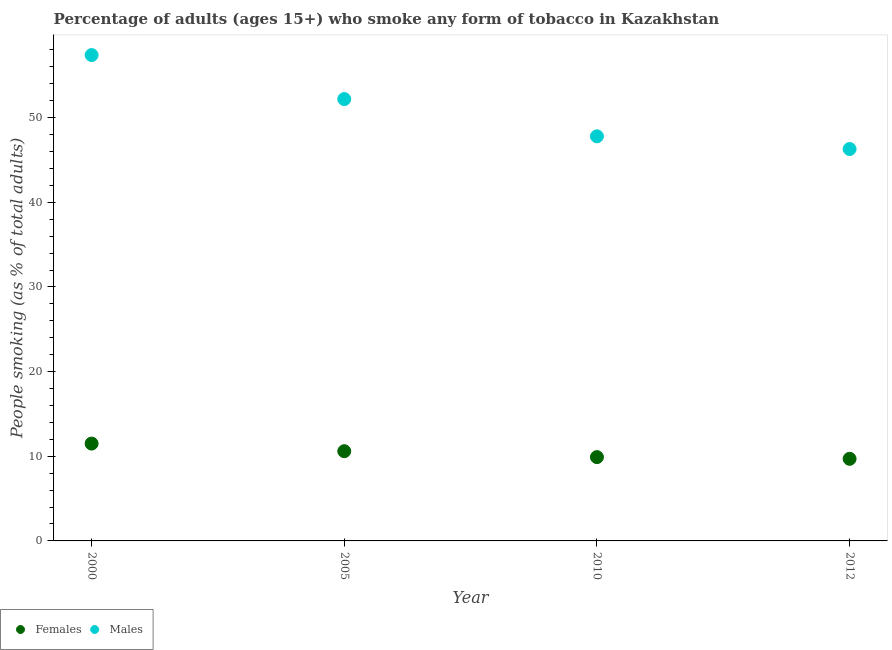Is the number of dotlines equal to the number of legend labels?
Offer a very short reply. Yes. What is the percentage of males who smoke in 2010?
Make the answer very short. 47.8. Across all years, what is the maximum percentage of males who smoke?
Ensure brevity in your answer.  57.4. Across all years, what is the minimum percentage of females who smoke?
Keep it short and to the point. 9.7. In which year was the percentage of males who smoke maximum?
Offer a terse response. 2000. In which year was the percentage of males who smoke minimum?
Give a very brief answer. 2012. What is the total percentage of females who smoke in the graph?
Make the answer very short. 41.7. What is the difference between the percentage of females who smoke in 2000 and that in 2012?
Offer a very short reply. 1.8. What is the difference between the percentage of males who smoke in 2012 and the percentage of females who smoke in 2005?
Give a very brief answer. 35.7. What is the average percentage of females who smoke per year?
Provide a succinct answer. 10.43. In the year 2012, what is the difference between the percentage of females who smoke and percentage of males who smoke?
Give a very brief answer. -36.6. What is the ratio of the percentage of females who smoke in 2010 to that in 2012?
Ensure brevity in your answer.  1.02. Is the percentage of females who smoke in 2000 less than that in 2010?
Your answer should be compact. No. What is the difference between the highest and the second highest percentage of males who smoke?
Give a very brief answer. 5.2. What is the difference between the highest and the lowest percentage of females who smoke?
Ensure brevity in your answer.  1.8. In how many years, is the percentage of females who smoke greater than the average percentage of females who smoke taken over all years?
Provide a short and direct response. 2. Is the percentage of females who smoke strictly less than the percentage of males who smoke over the years?
Make the answer very short. Yes. How many years are there in the graph?
Make the answer very short. 4. What is the difference between two consecutive major ticks on the Y-axis?
Offer a very short reply. 10. Are the values on the major ticks of Y-axis written in scientific E-notation?
Your response must be concise. No. Does the graph contain any zero values?
Ensure brevity in your answer.  No. Does the graph contain grids?
Offer a terse response. No. How many legend labels are there?
Make the answer very short. 2. What is the title of the graph?
Offer a very short reply. Percentage of adults (ages 15+) who smoke any form of tobacco in Kazakhstan. Does "Manufacturing industries and construction" appear as one of the legend labels in the graph?
Give a very brief answer. No. What is the label or title of the Y-axis?
Your response must be concise. People smoking (as % of total adults). What is the People smoking (as % of total adults) in Males in 2000?
Keep it short and to the point. 57.4. What is the People smoking (as % of total adults) in Males in 2005?
Keep it short and to the point. 52.2. What is the People smoking (as % of total adults) in Females in 2010?
Offer a terse response. 9.9. What is the People smoking (as % of total adults) in Males in 2010?
Give a very brief answer. 47.8. What is the People smoking (as % of total adults) in Females in 2012?
Make the answer very short. 9.7. What is the People smoking (as % of total adults) of Males in 2012?
Your answer should be compact. 46.3. Across all years, what is the maximum People smoking (as % of total adults) of Males?
Your answer should be very brief. 57.4. Across all years, what is the minimum People smoking (as % of total adults) in Males?
Offer a terse response. 46.3. What is the total People smoking (as % of total adults) of Females in the graph?
Give a very brief answer. 41.7. What is the total People smoking (as % of total adults) of Males in the graph?
Your answer should be very brief. 203.7. What is the difference between the People smoking (as % of total adults) in Females in 2000 and that in 2005?
Keep it short and to the point. 0.9. What is the difference between the People smoking (as % of total adults) of Males in 2000 and that in 2005?
Keep it short and to the point. 5.2. What is the difference between the People smoking (as % of total adults) of Males in 2000 and that in 2010?
Give a very brief answer. 9.6. What is the difference between the People smoking (as % of total adults) in Females in 2005 and that in 2010?
Your answer should be compact. 0.7. What is the difference between the People smoking (as % of total adults) in Females in 2005 and that in 2012?
Provide a short and direct response. 0.9. What is the difference between the People smoking (as % of total adults) of Males in 2005 and that in 2012?
Give a very brief answer. 5.9. What is the difference between the People smoking (as % of total adults) of Males in 2010 and that in 2012?
Ensure brevity in your answer.  1.5. What is the difference between the People smoking (as % of total adults) of Females in 2000 and the People smoking (as % of total adults) of Males in 2005?
Make the answer very short. -40.7. What is the difference between the People smoking (as % of total adults) in Females in 2000 and the People smoking (as % of total adults) in Males in 2010?
Keep it short and to the point. -36.3. What is the difference between the People smoking (as % of total adults) in Females in 2000 and the People smoking (as % of total adults) in Males in 2012?
Ensure brevity in your answer.  -34.8. What is the difference between the People smoking (as % of total adults) in Females in 2005 and the People smoking (as % of total adults) in Males in 2010?
Provide a short and direct response. -37.2. What is the difference between the People smoking (as % of total adults) of Females in 2005 and the People smoking (as % of total adults) of Males in 2012?
Your response must be concise. -35.7. What is the difference between the People smoking (as % of total adults) in Females in 2010 and the People smoking (as % of total adults) in Males in 2012?
Provide a short and direct response. -36.4. What is the average People smoking (as % of total adults) in Females per year?
Provide a succinct answer. 10.43. What is the average People smoking (as % of total adults) in Males per year?
Your response must be concise. 50.92. In the year 2000, what is the difference between the People smoking (as % of total adults) in Females and People smoking (as % of total adults) in Males?
Your response must be concise. -45.9. In the year 2005, what is the difference between the People smoking (as % of total adults) of Females and People smoking (as % of total adults) of Males?
Make the answer very short. -41.6. In the year 2010, what is the difference between the People smoking (as % of total adults) of Females and People smoking (as % of total adults) of Males?
Make the answer very short. -37.9. In the year 2012, what is the difference between the People smoking (as % of total adults) in Females and People smoking (as % of total adults) in Males?
Your answer should be compact. -36.6. What is the ratio of the People smoking (as % of total adults) in Females in 2000 to that in 2005?
Your response must be concise. 1.08. What is the ratio of the People smoking (as % of total adults) of Males in 2000 to that in 2005?
Provide a succinct answer. 1.1. What is the ratio of the People smoking (as % of total adults) of Females in 2000 to that in 2010?
Your answer should be very brief. 1.16. What is the ratio of the People smoking (as % of total adults) of Males in 2000 to that in 2010?
Ensure brevity in your answer.  1.2. What is the ratio of the People smoking (as % of total adults) in Females in 2000 to that in 2012?
Offer a very short reply. 1.19. What is the ratio of the People smoking (as % of total adults) in Males in 2000 to that in 2012?
Keep it short and to the point. 1.24. What is the ratio of the People smoking (as % of total adults) of Females in 2005 to that in 2010?
Offer a terse response. 1.07. What is the ratio of the People smoking (as % of total adults) of Males in 2005 to that in 2010?
Your answer should be very brief. 1.09. What is the ratio of the People smoking (as % of total adults) of Females in 2005 to that in 2012?
Your answer should be compact. 1.09. What is the ratio of the People smoking (as % of total adults) in Males in 2005 to that in 2012?
Keep it short and to the point. 1.13. What is the ratio of the People smoking (as % of total adults) of Females in 2010 to that in 2012?
Your response must be concise. 1.02. What is the ratio of the People smoking (as % of total adults) of Males in 2010 to that in 2012?
Your response must be concise. 1.03. What is the difference between the highest and the lowest People smoking (as % of total adults) in Females?
Provide a short and direct response. 1.8. What is the difference between the highest and the lowest People smoking (as % of total adults) in Males?
Your answer should be compact. 11.1. 